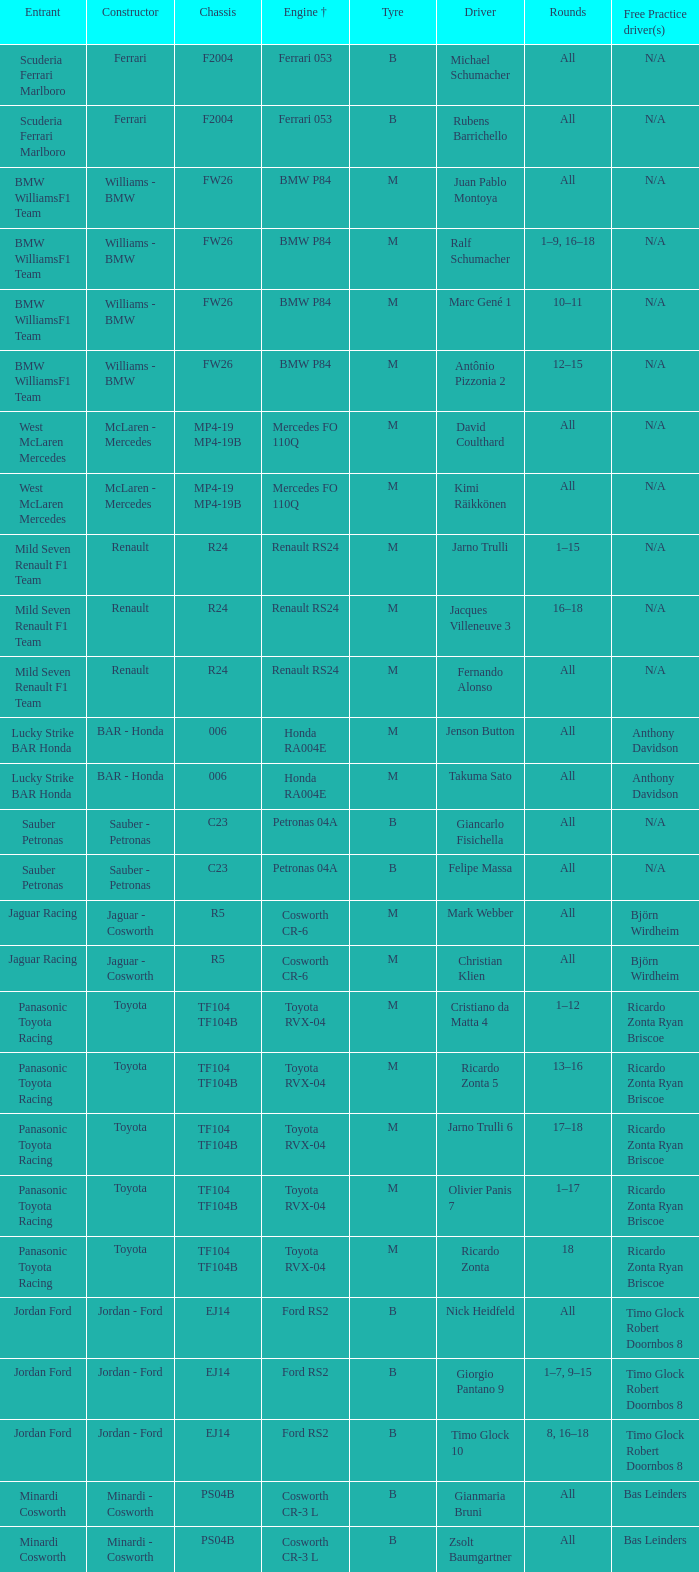Which kind of chassis is possessed by ricardo zonta? TF104 TF104B. 